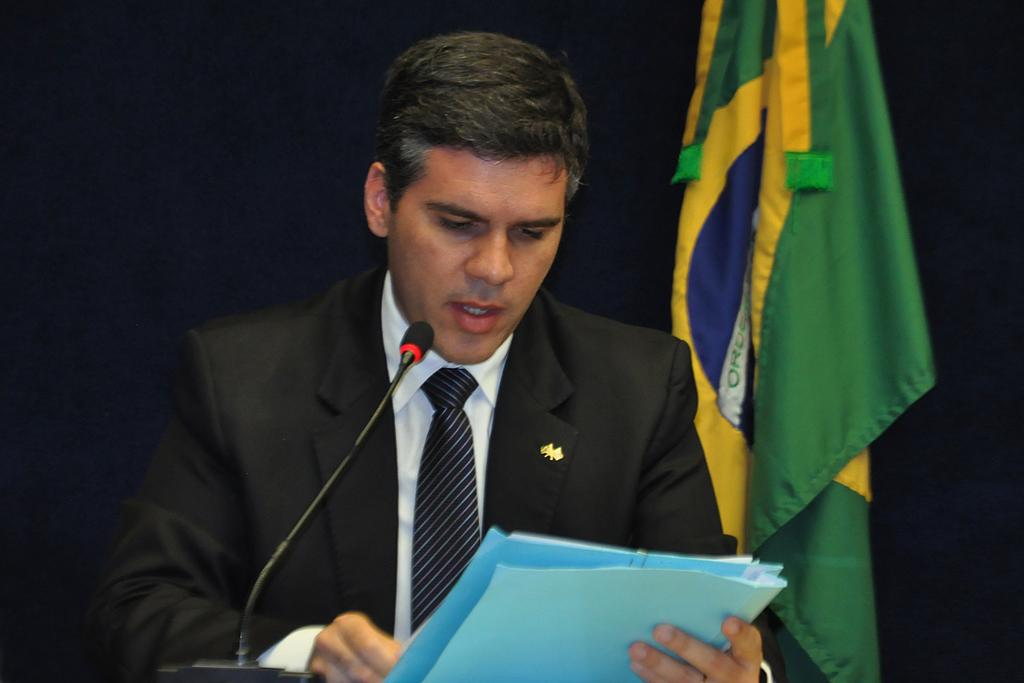Who is the main subject in the image? There is a man in the image. What is the man holding in the image? The man is holding a file. What object is in front of the man? There is a microphone in front of the man. What can be seen in the background of the image? There is a flag in the background of the image. What type of honey is being poured on the man's head in the image? There is no honey present in the image, and the man's head is not being poured on. 